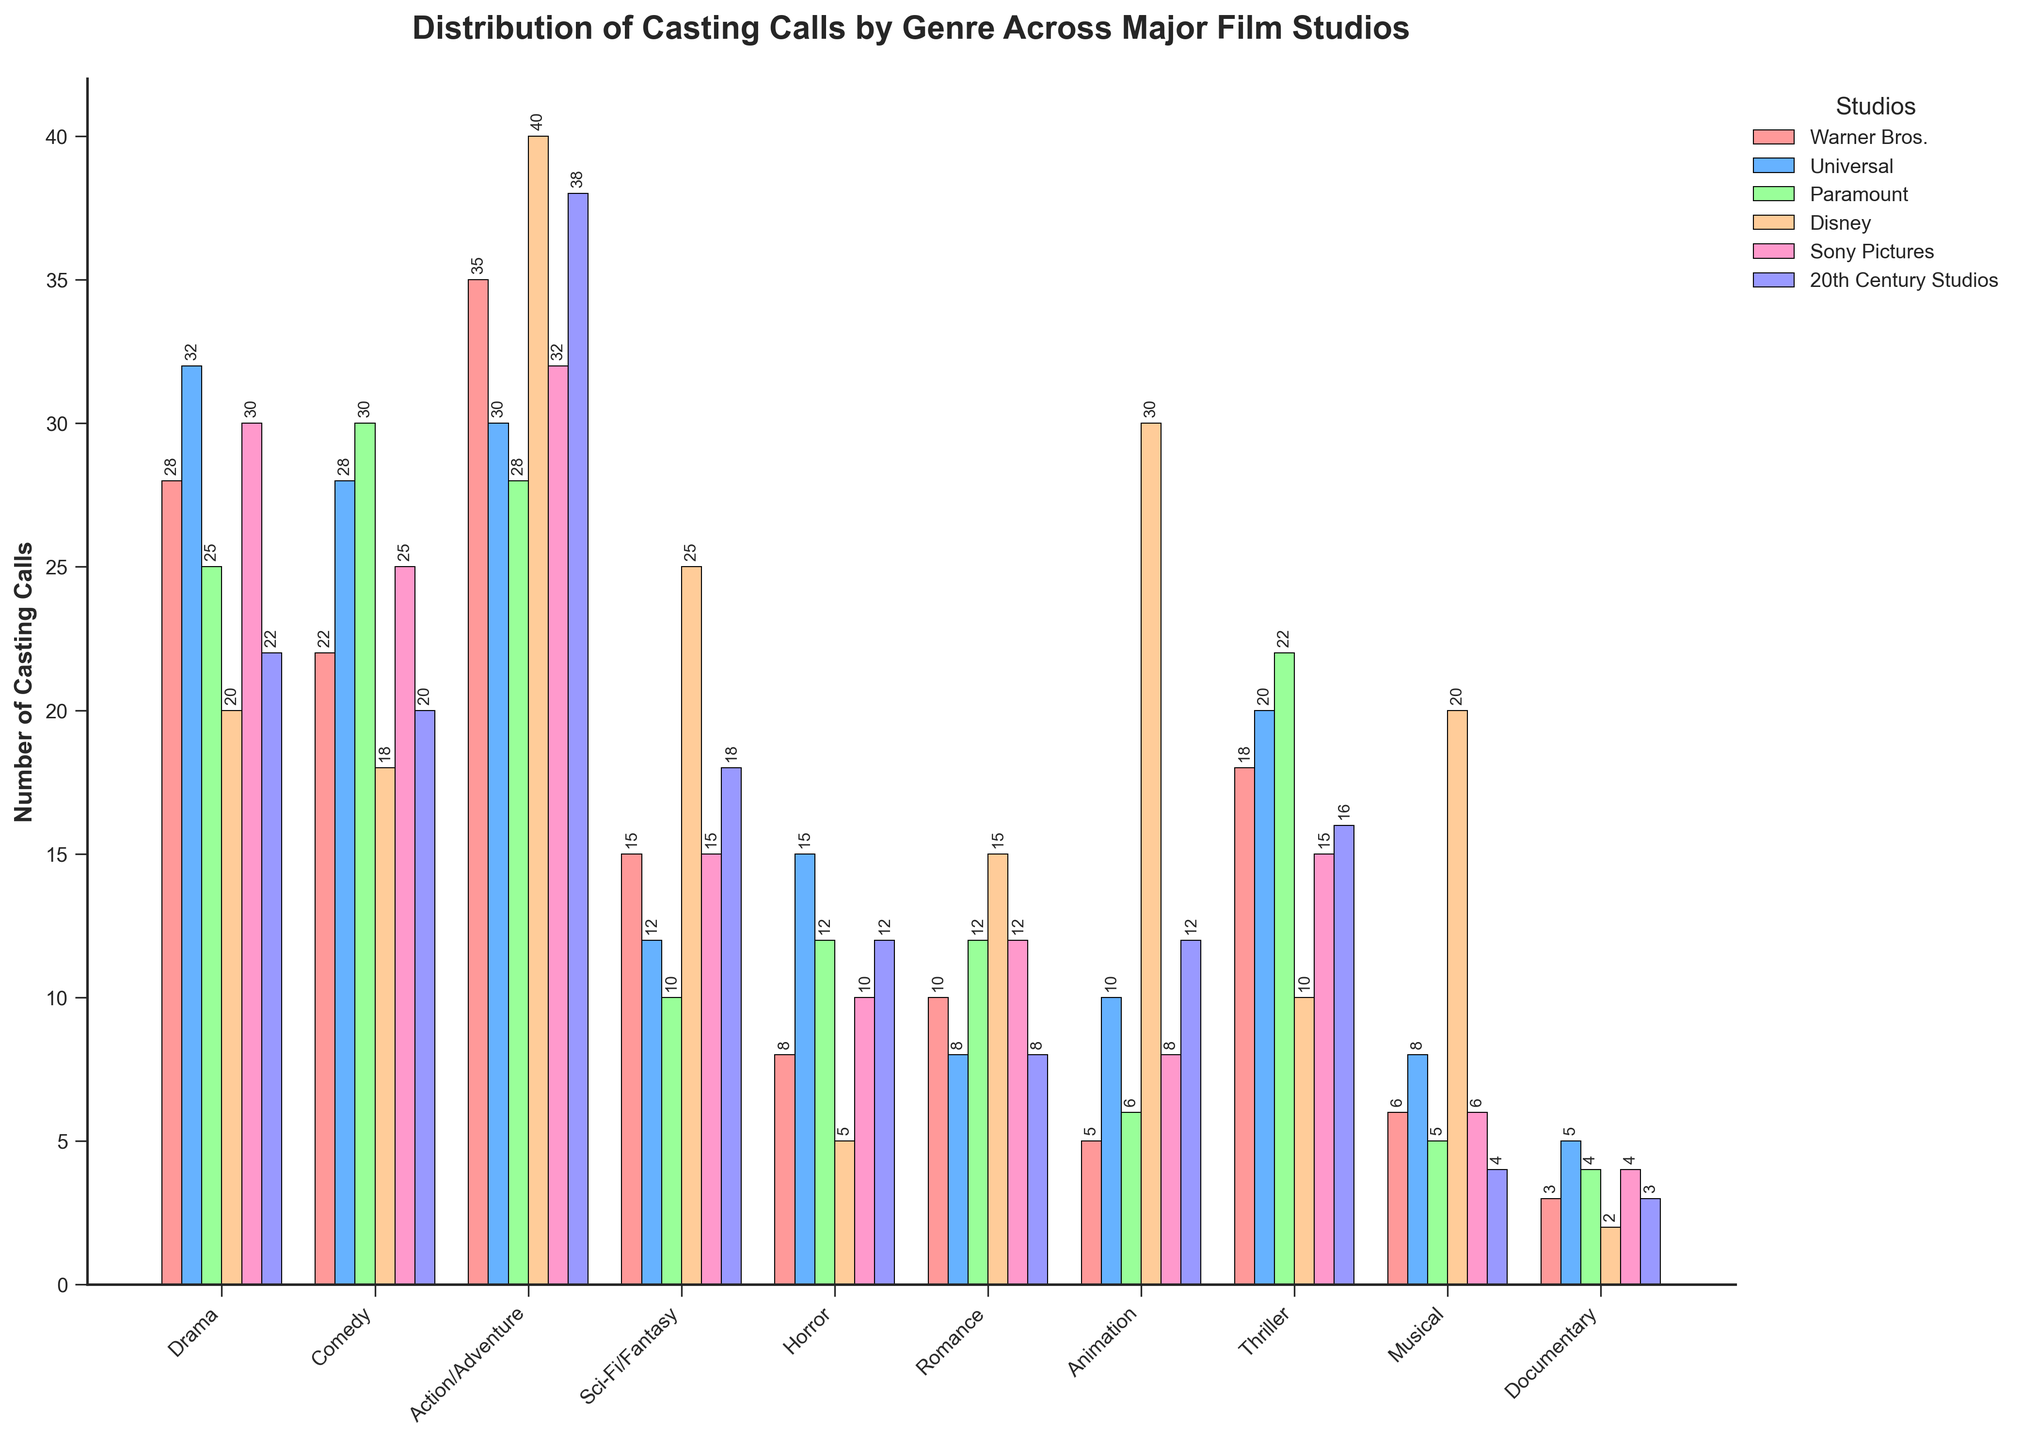What's the genre with the most casting calls for Disney? Look for the highest bar associated with Disney (light blue) across all genres. The highest bar for Disney is for "Animation" with 30 casting calls.
Answer: Animation Which studio has the least number of casting calls for Horror? Compare the bars representing each studio for Horror (sixth bar group). Disney (light purple) has the shortest bar with 5 casting calls.
Answer: Disney How many casting calls in total are there for Romance across all studios? Sum the values for Romance across all studios: 10 (Warner Bros) + 8 (Universal) + 12 (Paramount) + 15 (Disney) + 12 (Sony Pictures) + 8 (20th Century Studios) = 65
Answer: 65 Which two genres have the smallest differences in casting calls between Warner Bros. and Universal? Calculate the absolute differences for each genre: Drama (4), Comedy (6), Action/Adventure (5), Sci-Fi/Fantasy (3), Horror (7), Romance (2), Animation (5), Thriller (2), Musical (2), Documentary (2). The smallest differences are for Romance, Thriller, Musical, and Documentary at 2 each.
Answer: Romance, Thriller, Musical, Documentary What's the difference between the highest and lowest number of casting calls across all genres for 20th Century Studios? Identify the highest and lowest values for 20th Century Studios: highest is Action/Adventure (38), and lowest is Documentary (3). The difference is 38 - 3 = 35
Answer: 35 Which genre has the most balanced number of casting calls across all studios? Look for relatively similar height bars for each genre across all studios. Romance has values ranging between 8 and 15 across all studios, making it relatively balanced.
Answer: Romance Is there any genre where Warner Bros. has less than 10 casting calls? Check Warner Bros.' casting calls for each genre. "Horror" (8), Animation (5), Musical (6), and Documentary (3) are below 10.
Answer: Yes, Horror, Animation, Musical, Documentary Which studio has the highest average number of casting calls across all genres? Calculate the average casting calls for each studio. Warner Bros.: total 150 = (150/10) = 15. Universal: total 178 = (178/10) = 17.8. Paramount: total 154 = (154/10) = 15.4. Disney: total 185 = (185/10) = 18.5. Sony Pictures: total 152 = (152/10) = 15.2. 20th Century Studios: total 153 = (153/10) = 15.3. Disney has the highest average at 18.5.
Answer: Disney 